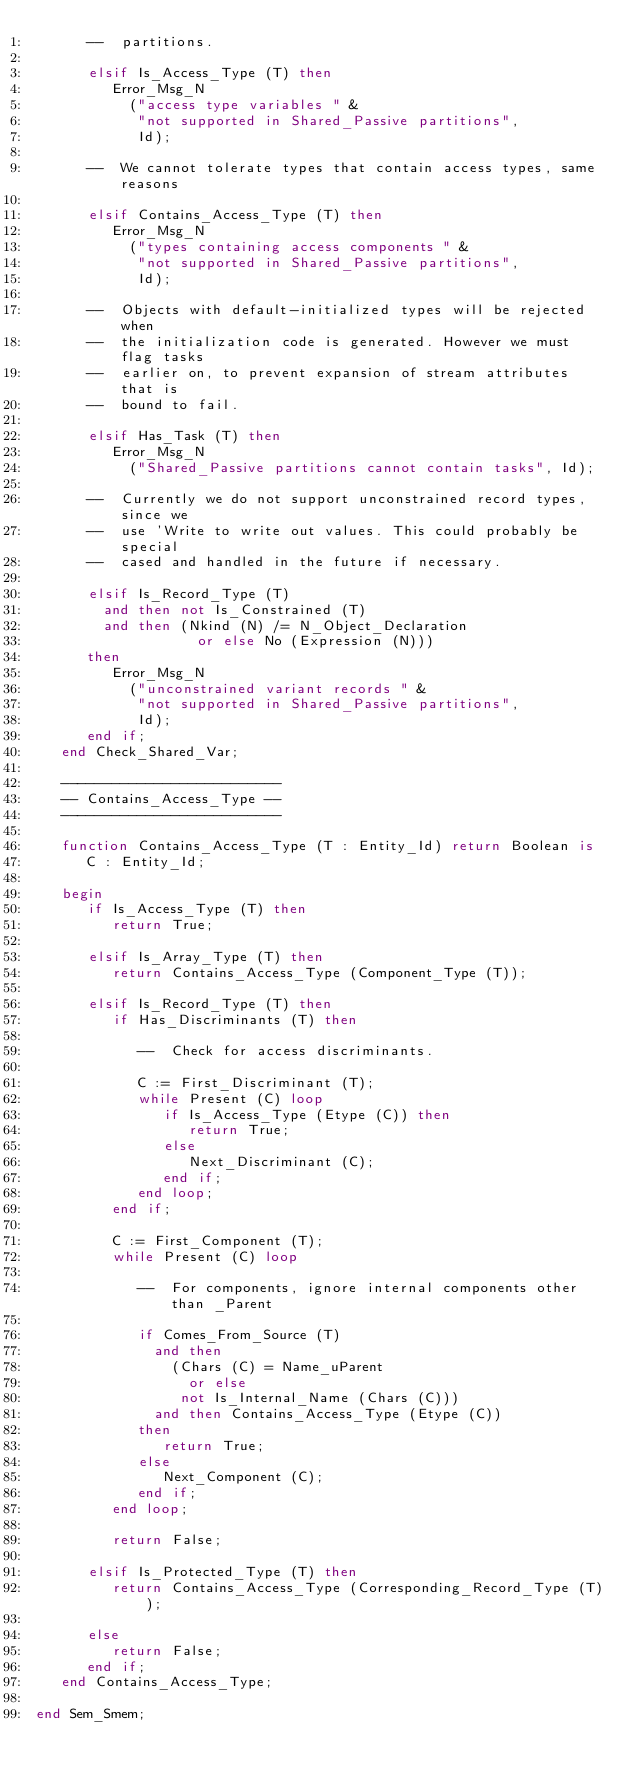<code> <loc_0><loc_0><loc_500><loc_500><_Ada_>      --  partitions.

      elsif Is_Access_Type (T) then
         Error_Msg_N
           ("access type variables " &
            "not supported in Shared_Passive partitions",
            Id);

      --  We cannot tolerate types that contain access types, same reasons

      elsif Contains_Access_Type (T) then
         Error_Msg_N
           ("types containing access components " &
            "not supported in Shared_Passive partitions",
            Id);

      --  Objects with default-initialized types will be rejected when
      --  the initialization code is generated. However we must flag tasks
      --  earlier on, to prevent expansion of stream attributes that is
      --  bound to fail.

      elsif Has_Task (T) then
         Error_Msg_N
           ("Shared_Passive partitions cannot contain tasks", Id);

      --  Currently we do not support unconstrained record types, since we
      --  use 'Write to write out values. This could probably be special
      --  cased and handled in the future if necessary.

      elsif Is_Record_Type (T)
        and then not Is_Constrained (T)
        and then (Nkind (N) /= N_Object_Declaration
                   or else No (Expression (N)))
      then
         Error_Msg_N
           ("unconstrained variant records " &
            "not supported in Shared_Passive partitions",
            Id);
      end if;
   end Check_Shared_Var;

   --------------------------
   -- Contains_Access_Type --
   --------------------------

   function Contains_Access_Type (T : Entity_Id) return Boolean is
      C : Entity_Id;

   begin
      if Is_Access_Type (T) then
         return True;

      elsif Is_Array_Type (T) then
         return Contains_Access_Type (Component_Type (T));

      elsif Is_Record_Type (T) then
         if Has_Discriminants (T) then

            --  Check for access discriminants.

            C := First_Discriminant (T);
            while Present (C) loop
               if Is_Access_Type (Etype (C)) then
                  return True;
               else
                  Next_Discriminant (C);
               end if;
            end loop;
         end if;

         C := First_Component (T);
         while Present (C) loop

            --  For components, ignore internal components other than _Parent

            if Comes_From_Source (T)
              and then
                (Chars (C) = Name_uParent
                  or else
                 not Is_Internal_Name (Chars (C)))
              and then Contains_Access_Type (Etype (C))
            then
               return True;
            else
               Next_Component (C);
            end if;
         end loop;

         return False;

      elsif Is_Protected_Type (T) then
         return Contains_Access_Type (Corresponding_Record_Type (T));

      else
         return False;
      end if;
   end Contains_Access_Type;

end Sem_Smem;
</code> 